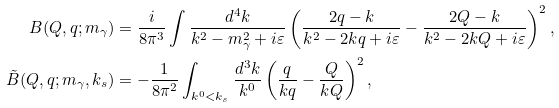Convert formula to latex. <formula><loc_0><loc_0><loc_500><loc_500>B ( Q , q ; m _ { \gamma } ) & = \frac { i } { 8 \pi ^ { 3 } } \int \frac { d ^ { 4 } k } { k ^ { 2 } - m _ { \gamma } ^ { 2 } + i \varepsilon } \left ( \frac { 2 q - k } { k ^ { 2 } - 2 k q + i \varepsilon } - \frac { 2 Q - k } { k ^ { 2 } - 2 k Q + i \varepsilon } \right ) ^ { 2 } , \\ \tilde { B } ( Q , q ; m _ { \gamma } , k _ { s } ) & = - \frac { 1 } { 8 \pi ^ { 2 } } \int _ { k ^ { 0 } < k _ { s } } \frac { d ^ { 3 } k } { k ^ { 0 } } \left ( \frac { q } { k q } - \frac { Q } { k Q } \right ) ^ { 2 } ,</formula> 